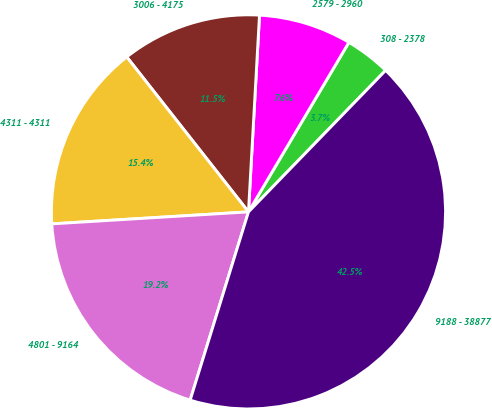Convert chart. <chart><loc_0><loc_0><loc_500><loc_500><pie_chart><fcel>308 - 2378<fcel>2579 - 2960<fcel>3006 - 4175<fcel>4311 - 4311<fcel>4801 - 9164<fcel>9188 - 38877<nl><fcel>3.74%<fcel>7.62%<fcel>11.49%<fcel>15.37%<fcel>19.25%<fcel>42.53%<nl></chart> 